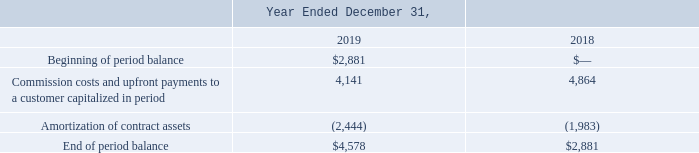Note 3. Revenue from Contracts with Customers
Contract Assets
Our contract assets consist of capitalized commission costs and upfront payments made to customers. The current portion of capitalized commission costs and upfront payments made to customers are included in other current assets within our consolidated balance sheets. The non-current portion of capitalized commission costs and upfront payments made to customers are reflected in other assets within our consolidated balance sheets. Our amortization of contract assets during the years ended December 31, 2019 and 2018 were $2.4 million and $2.0 million, respectively. There were no amortized commission costs during the year ended December 31, 2017.
We review the capitalized costs for impairment at least annually. Impairment exists if the carrying amount of the asset recognized from contract costs exceeds the remaining amount of consideration we expect to receive in exchange for providing the goods and services to which such asset relates, less the costs that relate directly to providing those good and services and that have not been recognized as an expense. We did not record an impairment loss on our contract assets during the years ended December 31, 2019, 2018 and 2017.
The changes in our contract assets are as follows (in thousands):
What does the company's contract assets consist of? Capitalized commission costs and upfront payments made to customers. Where does the company include the non-current portion of capitalized commission costs and upfront payments made to customers in their consolidated balance sheets? Other assets. What was the Commission costs and upfront payments to a customer capitalized in period in 2019?
Answer scale should be: thousand. 4,141. What was the change between the beginning of period balance and end of period balance in 2019?
Answer scale should be: thousand. 4,578-2,881
Answer: 1697. How many years did Commission costs and upfront payments to a customer capitalized in period exceed $4,500 thousand? 2018
Answer: 1. What was the percentage change in the Amortization of contract assets between 2018 and 2019?
Answer scale should be: percent. (-2,444+1,983)/-1,983
Answer: 23.25. 